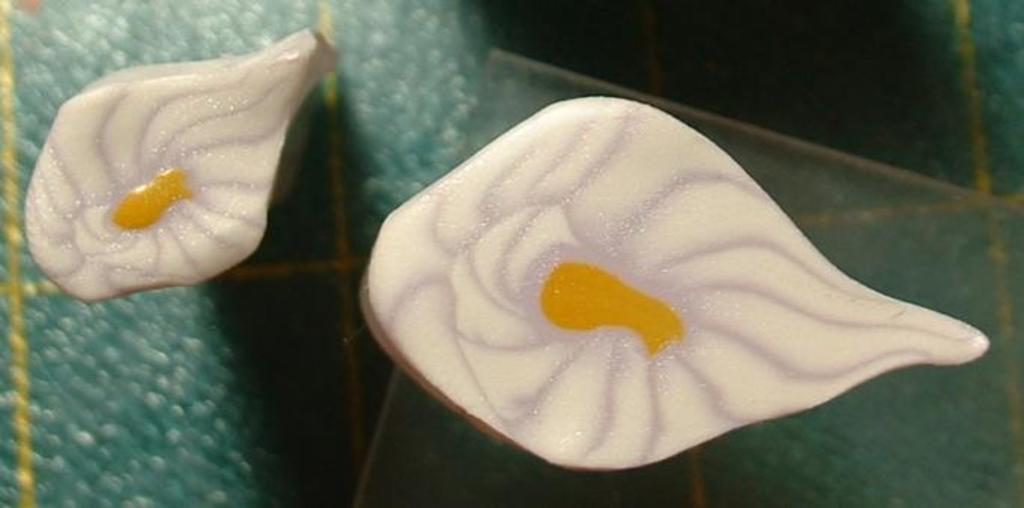What are the two white objects in the image? There are two white objects in the image. What is the color of the surface on which the objects are placed? The objects are on a green surface. What reason does the uncle have for sorting the objects in the image? There is no uncle present in the image, and therefore no reason for sorting objects can be determined. 